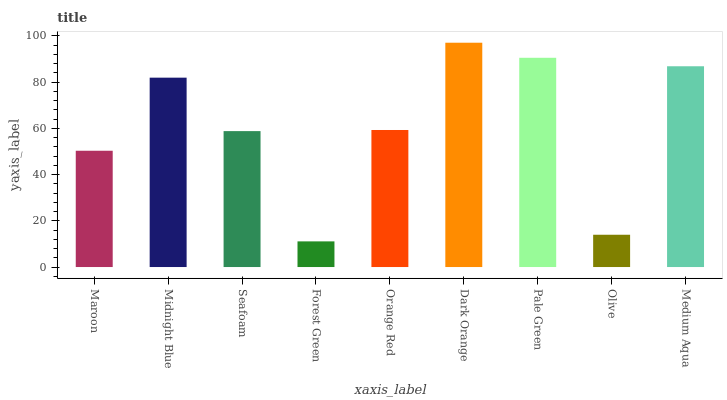Is Forest Green the minimum?
Answer yes or no. Yes. Is Dark Orange the maximum?
Answer yes or no. Yes. Is Midnight Blue the minimum?
Answer yes or no. No. Is Midnight Blue the maximum?
Answer yes or no. No. Is Midnight Blue greater than Maroon?
Answer yes or no. Yes. Is Maroon less than Midnight Blue?
Answer yes or no. Yes. Is Maroon greater than Midnight Blue?
Answer yes or no. No. Is Midnight Blue less than Maroon?
Answer yes or no. No. Is Orange Red the high median?
Answer yes or no. Yes. Is Orange Red the low median?
Answer yes or no. Yes. Is Forest Green the high median?
Answer yes or no. No. Is Maroon the low median?
Answer yes or no. No. 